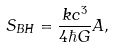<formula> <loc_0><loc_0><loc_500><loc_500>S _ { B H } = { \frac { k c ^ { 3 } } { 4 \hbar { G } } } A ,</formula> 